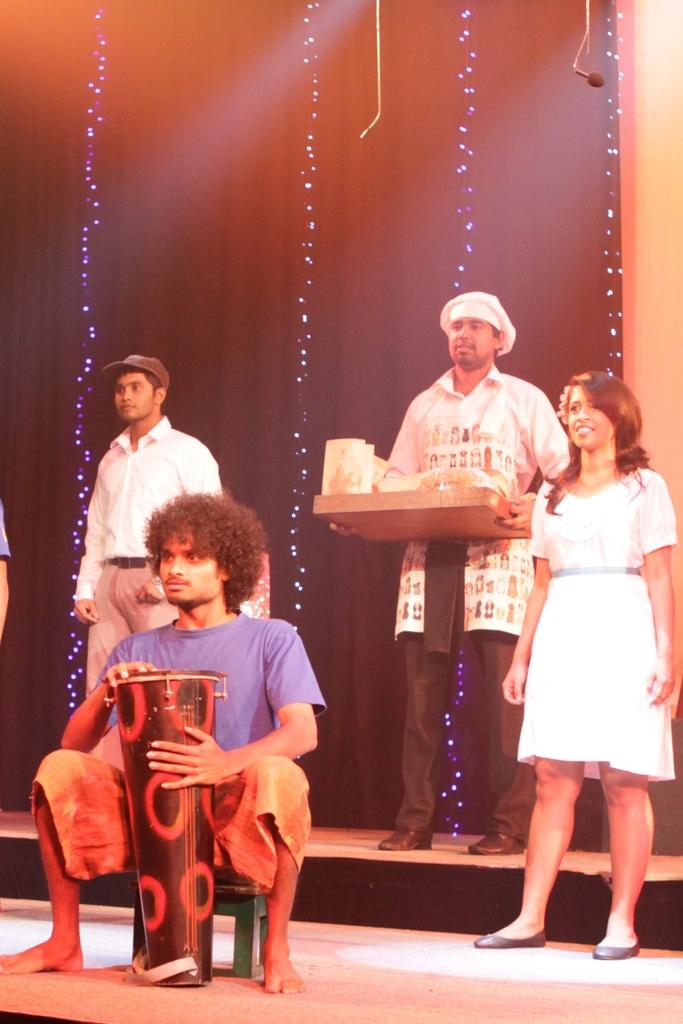What is the person in the image wearing? The person in the image is wearing a blue shirt. What is the person doing while wearing the blue shirt? The person is sitting on a stool. What is the person holding while sitting on the stool? The person is holding a musical instrument. Are there any other people in the image? Yes, there are other persons standing behind the person with the musical instrument. What type of plantation can be seen in the background of the image? There is no plantation visible in the image. How many masses are being performed by the person with the musical instrument? The person with the musical instrument is not performing any masses in the image. 